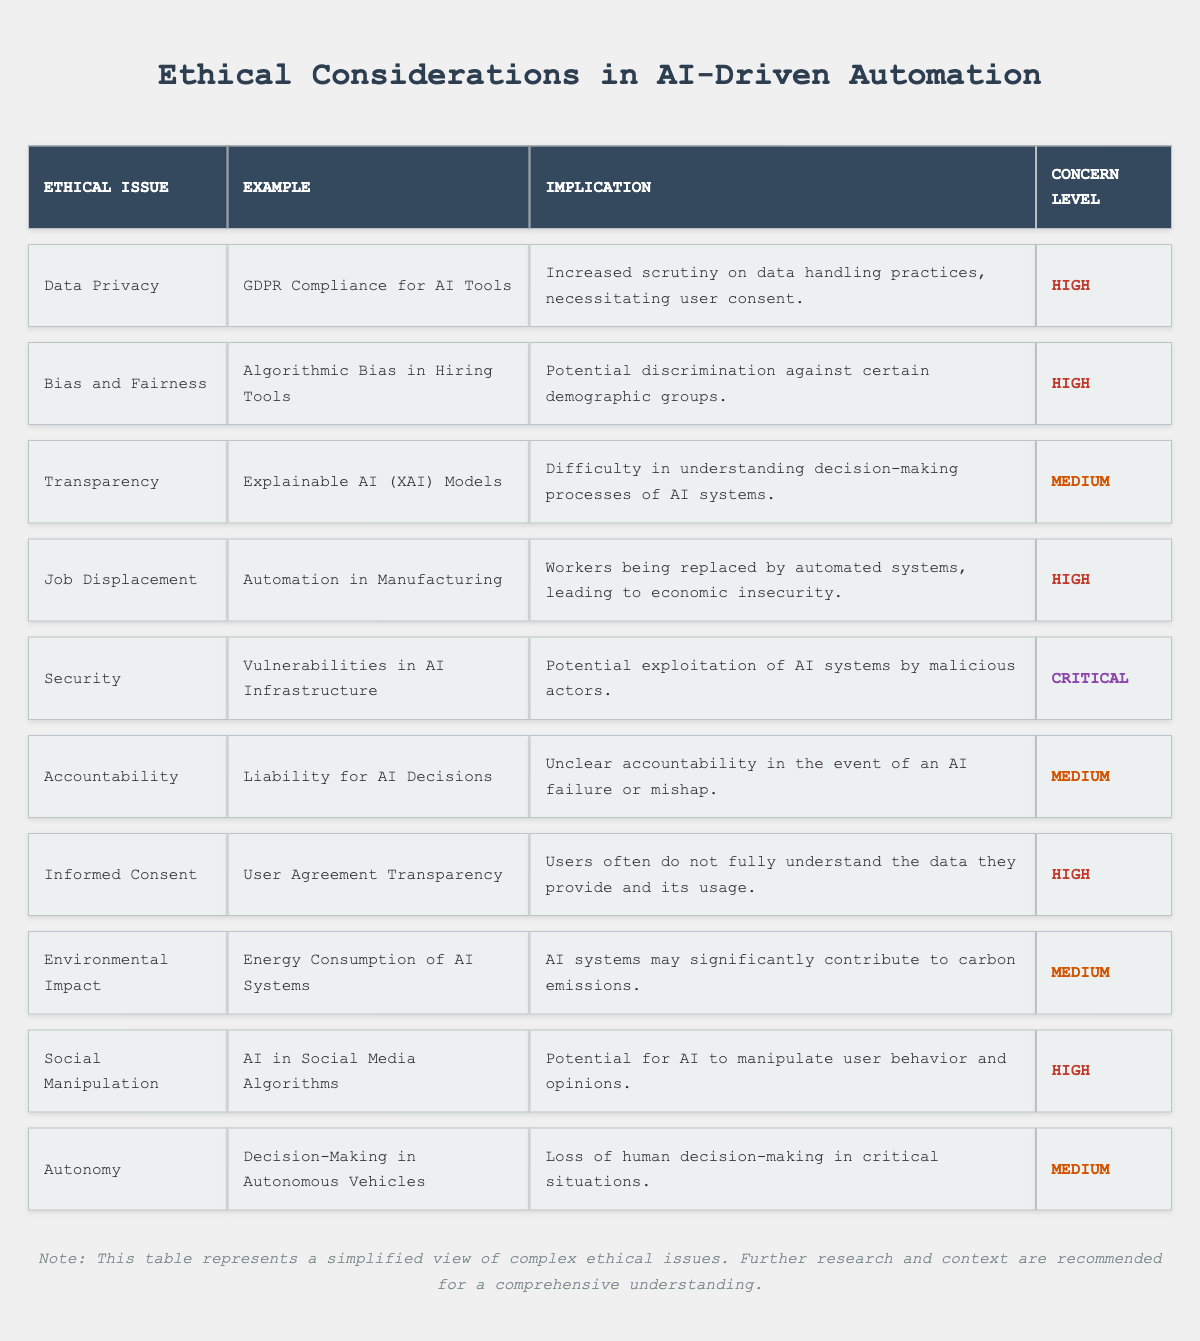What is the top ethical concern regarding AI-driven automation tools? According to the table, the most critical concern is "Security," which has the highest level of concern labeled as "Critical."
Answer: Security How many ethical issues listed in the table have a high concern level? The table shows four issues with a "High" concern level: Data Privacy, Bias and Fairness, Job Displacement, and Informed Consent.
Answer: Four Is "Transparency" listed as a concern for AI-driven automation tools? Yes, "Transparency" is indeed listed as an ethical issue in the table.
Answer: Yes What is the implication of "Social Manipulation" as shown in the table? The implication of "Social Manipulation" is the potential for AI to manipulate user behavior and opinions, which can have significant effects on individuals and society.
Answer: Potential for manipulation What is the average concern level for the ethical issues that have a medium concern level? There are four issues with a "Medium" concern level (Transparency, Accountability, Environmental Impact, Autonomy). The count is 4, and since "Medium" is represented numerically as 2 for average calculation purposes, the average would also be 2 (which aligns with "Medium").
Answer: Medium Which ethical issue involves the potential replacement of workers? "Job Displacement" is the ethical issue that addresses the potential replacement of workers due to automation in manufacturing processes.
Answer: Job Displacement What is the example given for the ethical issue of "Bias and Fairness"? The example under "Bias and Fairness" is "Algorithmic Bias in Hiring Tools."
Answer: Algorithmic Bias in Hiring Tools Is "Informed Consent" seen as a critical concern? No, "Informed Consent" is labeled as a concern with a "High" level but not "Critical."
Answer: No Could the AI infrastructure be vulnerable to exploitation? Yes, the table explicitly states that vulnerabilities in AI infrastructure could lead to exploitation by malicious actors.
Answer: Yes How does the concern level of "Security" compare to that of "Accountability"? "Security" is labeled as "Critical," while "Accountability" is categorized under "Medium," indicating that "Security" is a higher concern than "Accountability."
Answer: Security is Critical, Accountability is Medium 